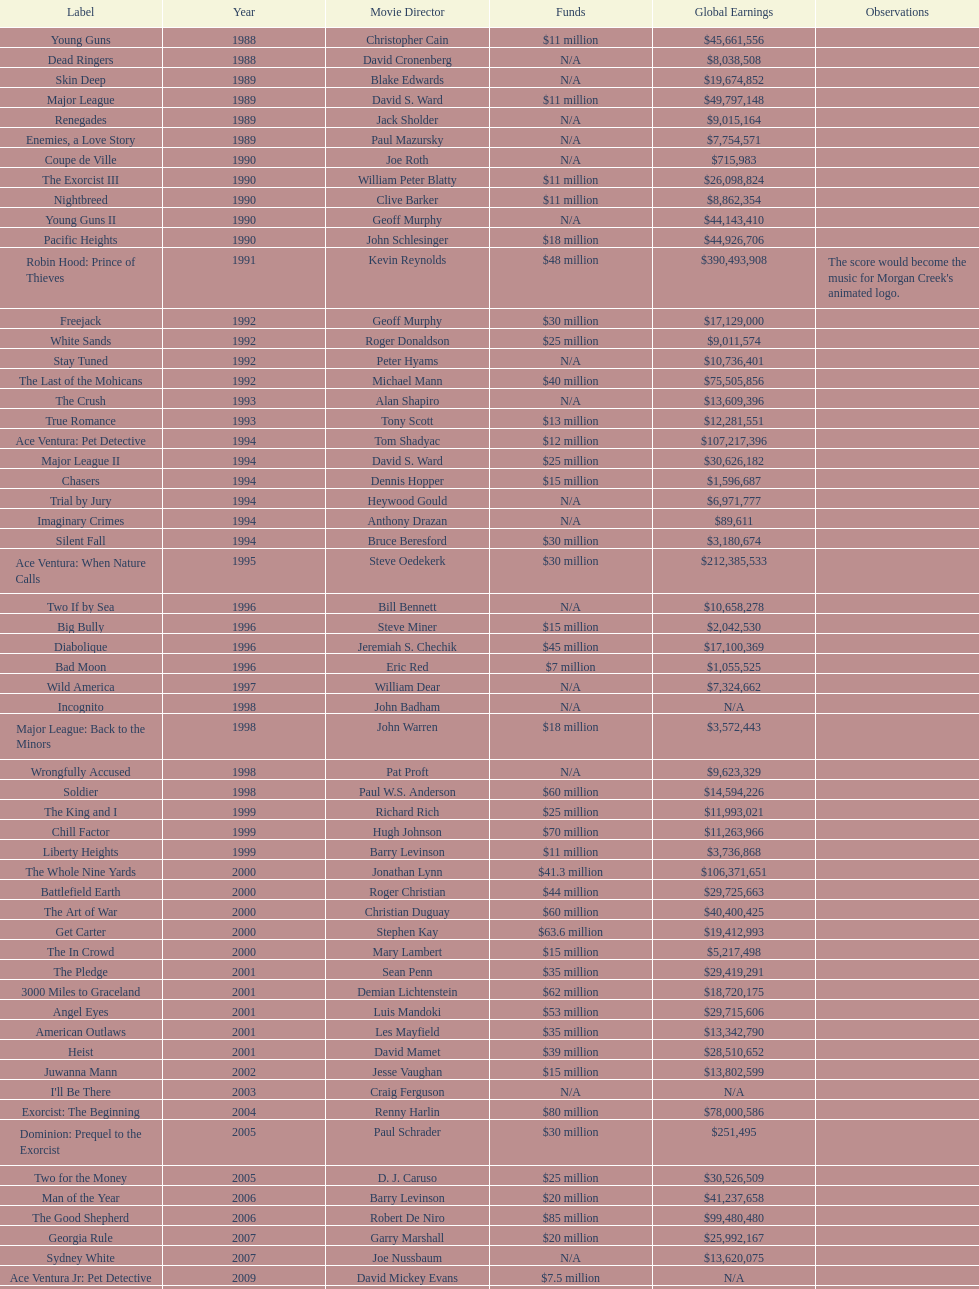Was the budget for young guns more or less than freejack's budget? Less. 